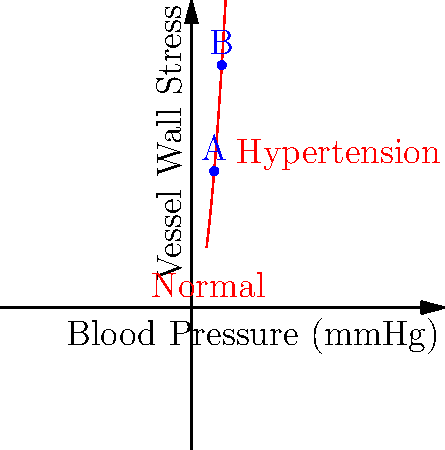In the graph above, points A and B represent the vessel wall stress at different blood pressure levels. If point A corresponds to a normal blood pressure of 120 mmHg, and point B represents a hypertensive state of 160 mmHg, by approximately what factor does the vessel wall stress increase from A to B? Let's approach this step-by-step:

1. The graph shows a non-linear relationship between blood pressure and vessel wall stress.

2. We can see that the curve is parabolic, suggesting a square relationship.

3. Let's call the stress at point A as $S_A$ and at point B as $S_B$.

4. Given the parabolic nature, we can assume the relationship is of the form $S = k \cdot P^2$, where $S$ is stress, $k$ is a constant, and $P$ is pressure.

5. For point A: $S_A = k \cdot 120^2 = 14400k$

6. For point B: $S_B = k \cdot 160^2 = 25600k$

7. To find the factor of increase, we divide $S_B$ by $S_A$:

   $$\frac{S_B}{S_A} = \frac{25600k}{14400k} = \frac{25600}{14400} = 1.7777...$$

8. This is approximately equal to $(\frac{160}{120})^2 = (\frac{4}{3})^2 = 1.7777...$

Therefore, the vessel wall stress increases by a factor of approximately 1.78 or 78% from point A to point B.
Answer: 1.78 